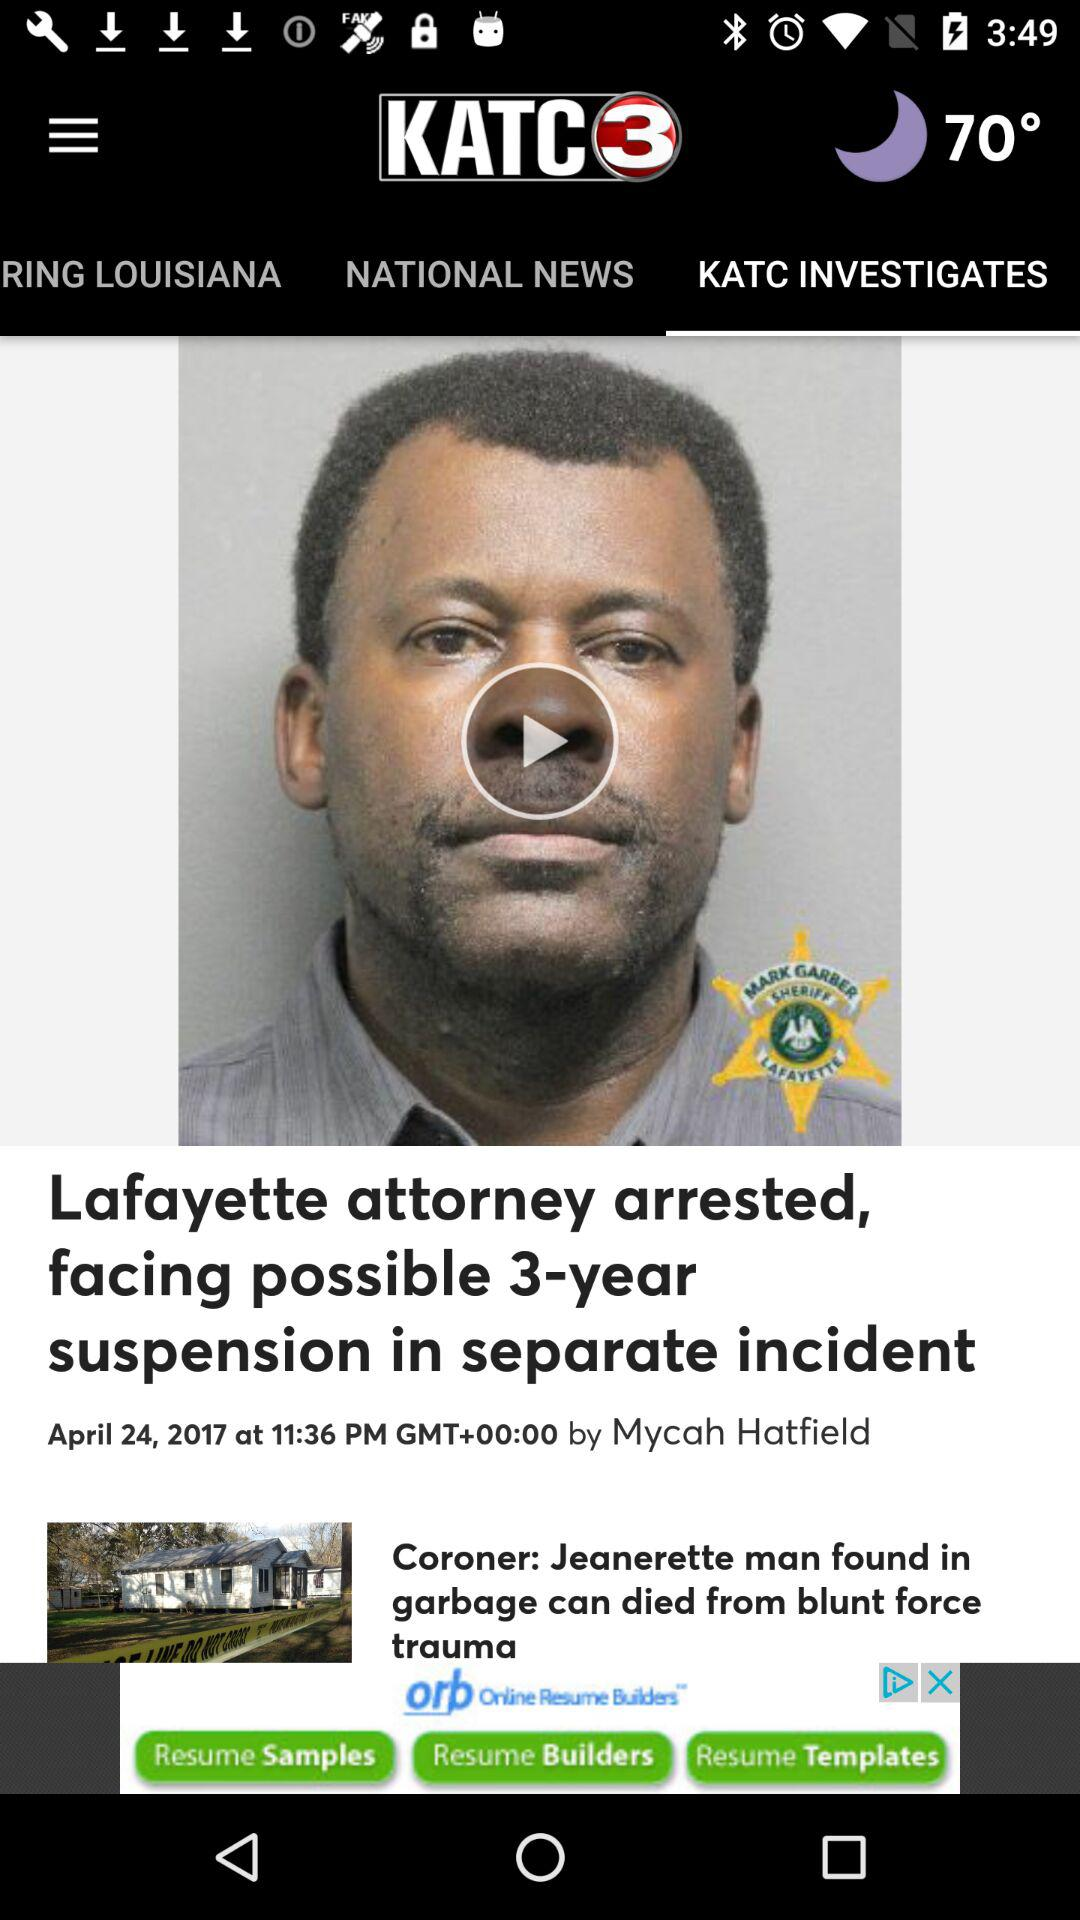What is the author's name? The author's name is Mycah Hatfield. 